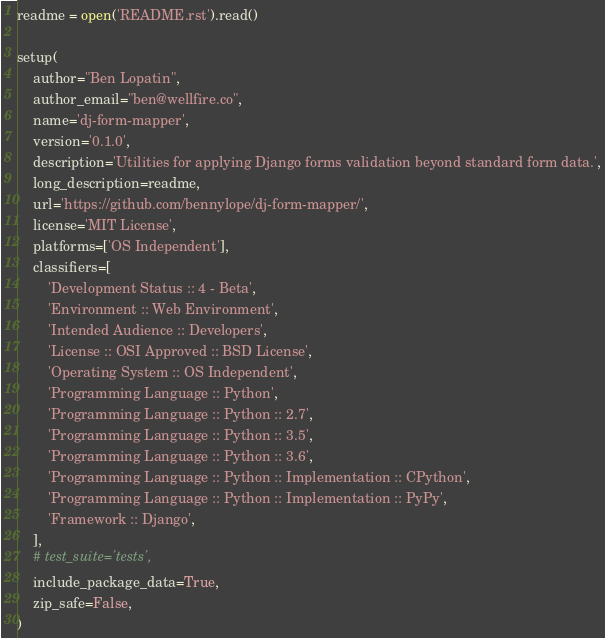Convert code to text. <code><loc_0><loc_0><loc_500><loc_500><_Python_>readme = open('README.rst').read()

setup(
    author="Ben Lopatin",
    author_email="ben@wellfire.co",
    name='dj-form-mapper',
    version='0.1.0',
    description='Utilities for applying Django forms validation beyond standard form data.',
    long_description=readme,
    url='https://github.com/bennylope/dj-form-mapper/',
    license='MIT License',
    platforms=['OS Independent'],
    classifiers=[
        'Development Status :: 4 - Beta',
        'Environment :: Web Environment',
        'Intended Audience :: Developers',
        'License :: OSI Approved :: BSD License',
        'Operating System :: OS Independent',
        'Programming Language :: Python',
        'Programming Language :: Python :: 2.7',
        'Programming Language :: Python :: 3.5',
        'Programming Language :: Python :: 3.6',
        'Programming Language :: Python :: Implementation :: CPython',
        'Programming Language :: Python :: Implementation :: PyPy',
        'Framework :: Django',
    ],
    # test_suite='tests',
    include_package_data=True,
    zip_safe=False,
)
</code> 